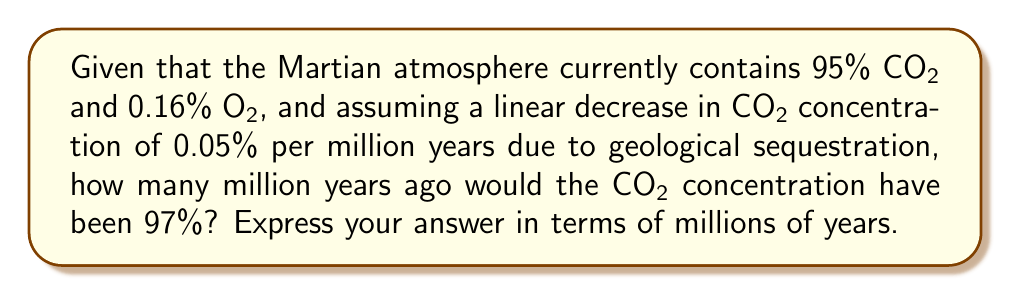Can you solve this math problem? To solve this problem, we need to use a linear equation to model the change in CO₂ concentration over time. Let's approach this step-by-step:

1) Let $x$ be the number of millions of years ago, and $y$ be the CO₂ concentration as a percentage.

2) We know two points on this line:
   - Current point (0, 95), where 0 is now and 95 is the current CO₂ percentage
   - Unknown point (x, 97), where x is what we're solving for and 97 is the past CO₂ percentage

3) The slope of the line is -0.05% per million years. In point-slope form, our equation is:

   $y - y_1 = m(x - x_1)$

   Where $(x_1, y_1)$ is our known point (0, 95) and $m$ is our slope -0.05.

4) Substituting these values:

   $y - 95 = -0.05(x - 0)$

5) Simplify:

   $y - 95 = -0.05x$

6) We want to find x when y = 97. Substitute this:

   $97 - 95 = -0.05x$

7) Simplify:

   $2 = -0.05x$

8) Solve for x:

   $x = -\frac{2}{-0.05} = 40$

Therefore, the CO₂ concentration would have been 97% 40 million years ago.
Answer: 40 million years 